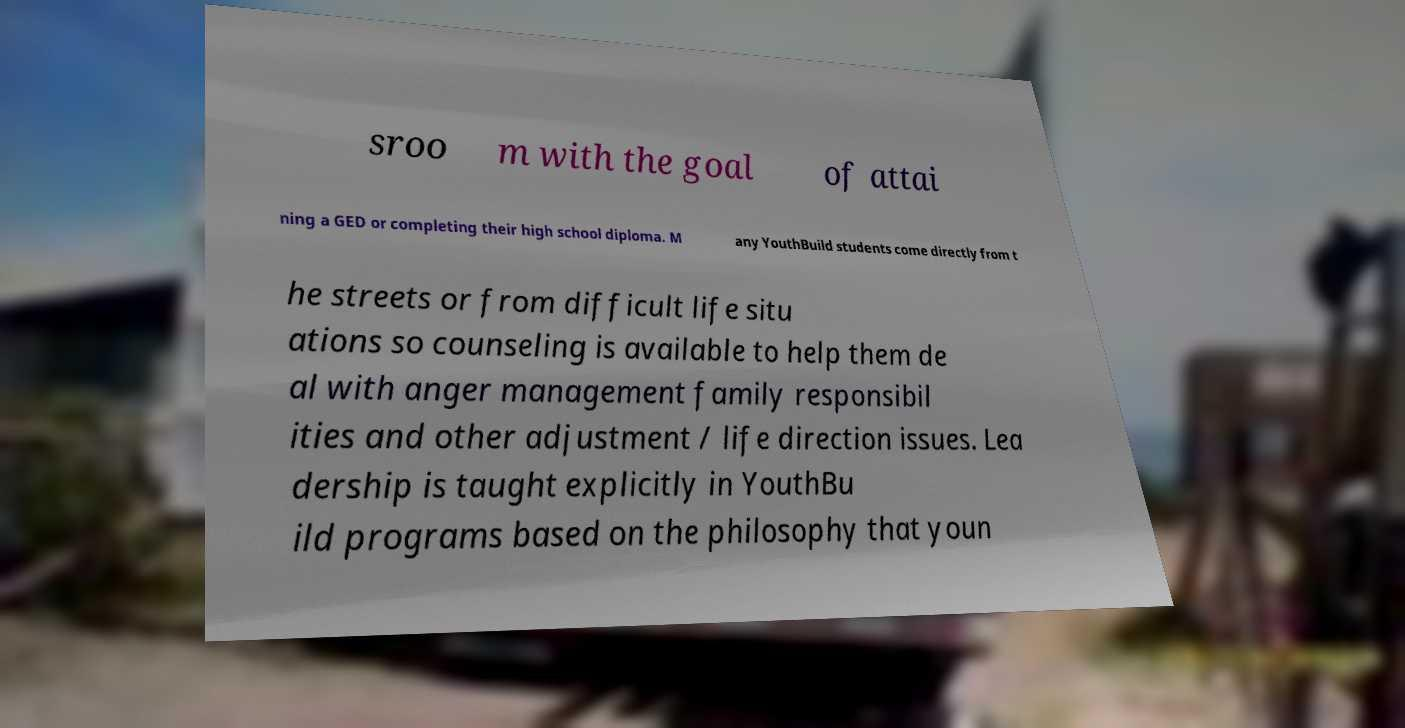Could you assist in decoding the text presented in this image and type it out clearly? sroo m with the goal of attai ning a GED or completing their high school diploma. M any YouthBuild students come directly from t he streets or from difficult life situ ations so counseling is available to help them de al with anger management family responsibil ities and other adjustment / life direction issues. Lea dership is taught explicitly in YouthBu ild programs based on the philosophy that youn 